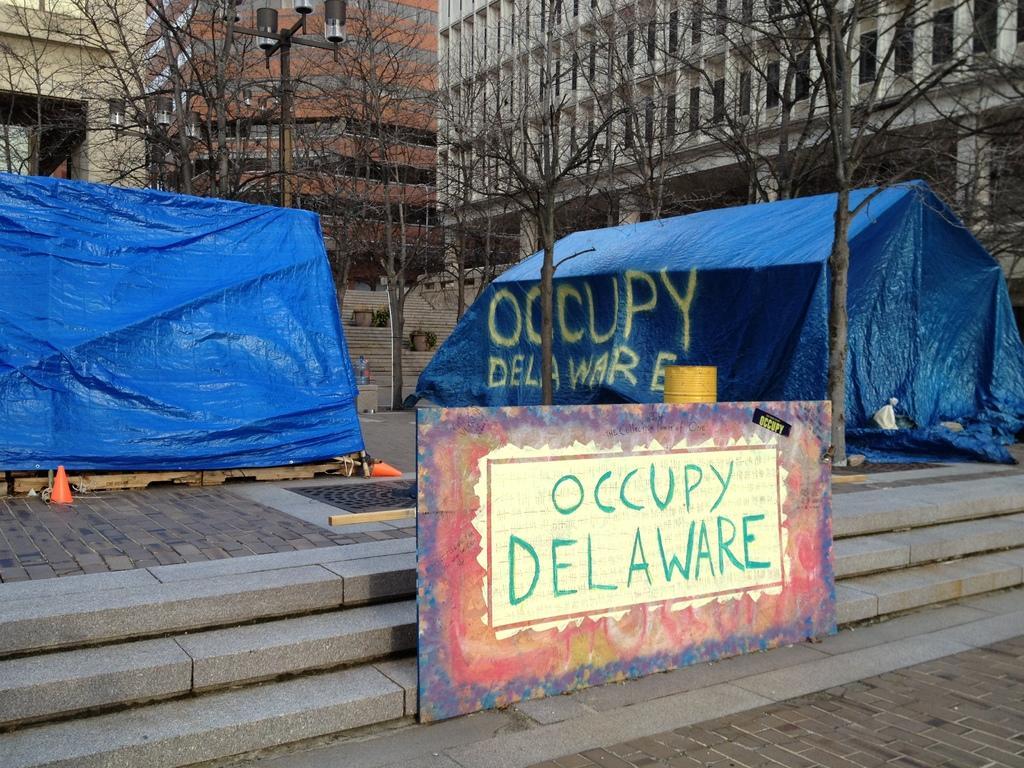Could you give a brief overview of what you see in this image? In the image there is a board with something written on it. Behind the board there are steps. There are blue color huts on the floor and also there are trees. In the background there are buildings with walls and windows. 